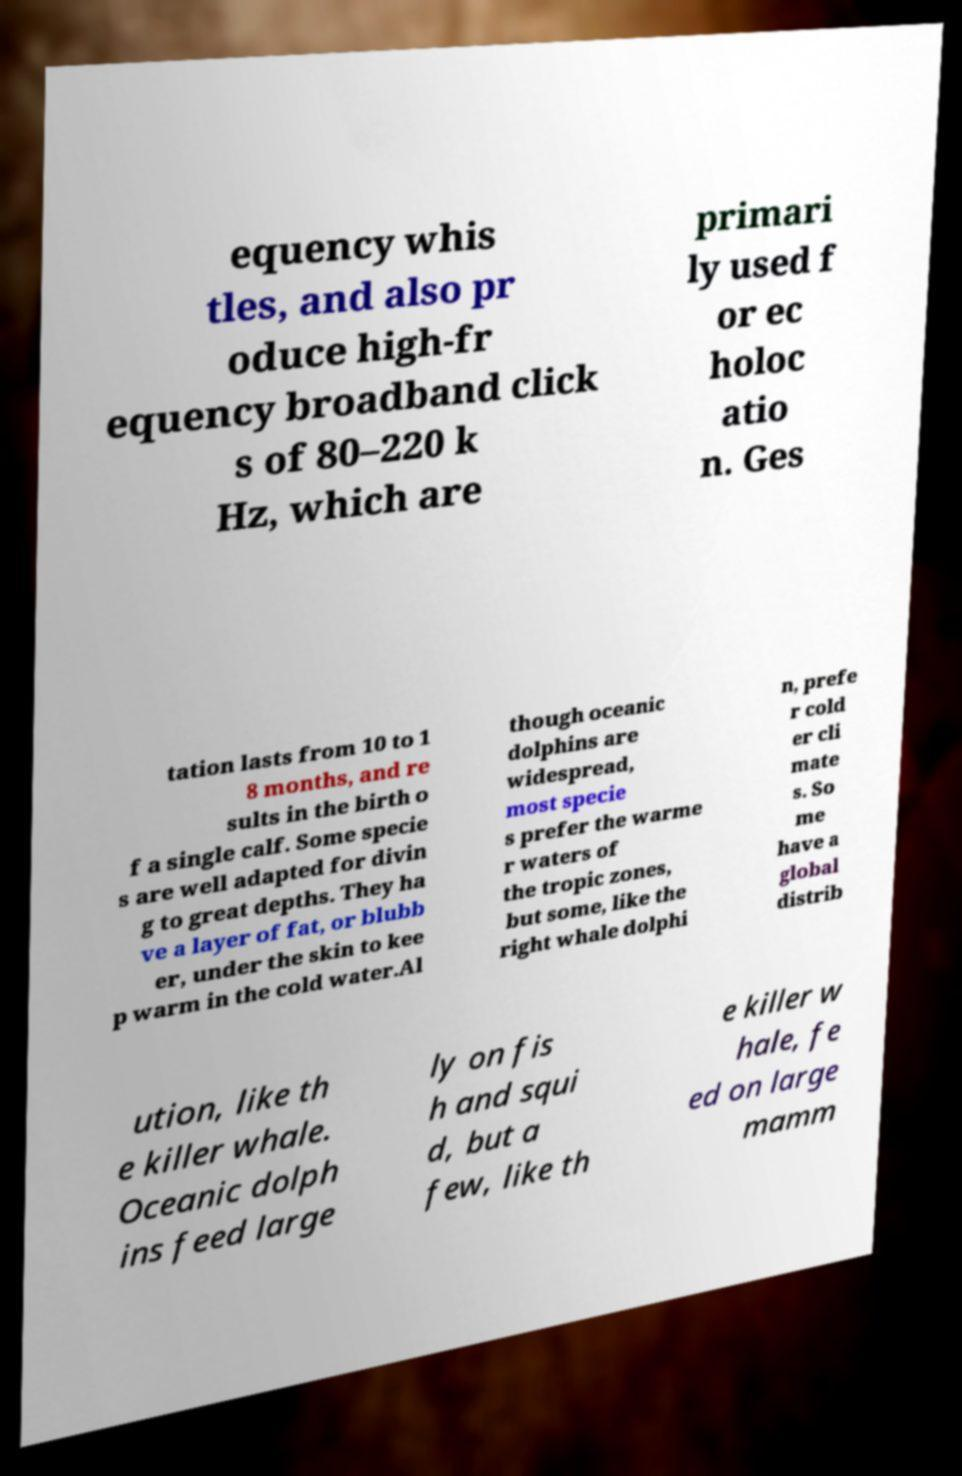There's text embedded in this image that I need extracted. Can you transcribe it verbatim? equency whis tles, and also pr oduce high-fr equency broadband click s of 80–220 k Hz, which are primari ly used f or ec holoc atio n. Ges tation lasts from 10 to 1 8 months, and re sults in the birth o f a single calf. Some specie s are well adapted for divin g to great depths. They ha ve a layer of fat, or blubb er, under the skin to kee p warm in the cold water.Al though oceanic dolphins are widespread, most specie s prefer the warme r waters of the tropic zones, but some, like the right whale dolphi n, prefe r cold er cli mate s. So me have a global distrib ution, like th e killer whale. Oceanic dolph ins feed large ly on fis h and squi d, but a few, like th e killer w hale, fe ed on large mamm 